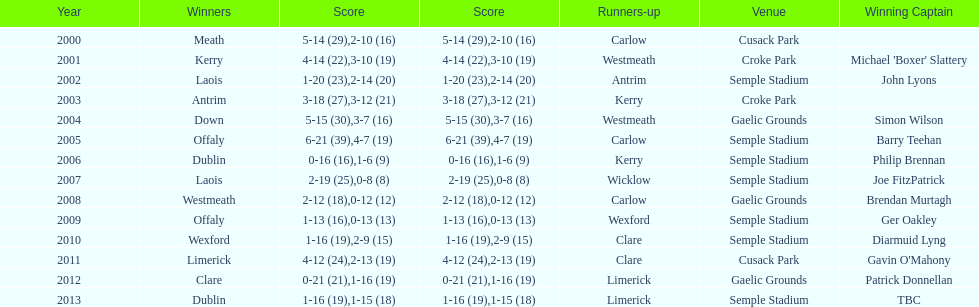On how many occasions was carlow the one in second place? 3. 